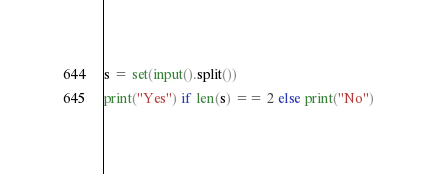<code> <loc_0><loc_0><loc_500><loc_500><_Python_>s = set(input().split())
print("Yes") if len(s) == 2 else print("No")</code> 